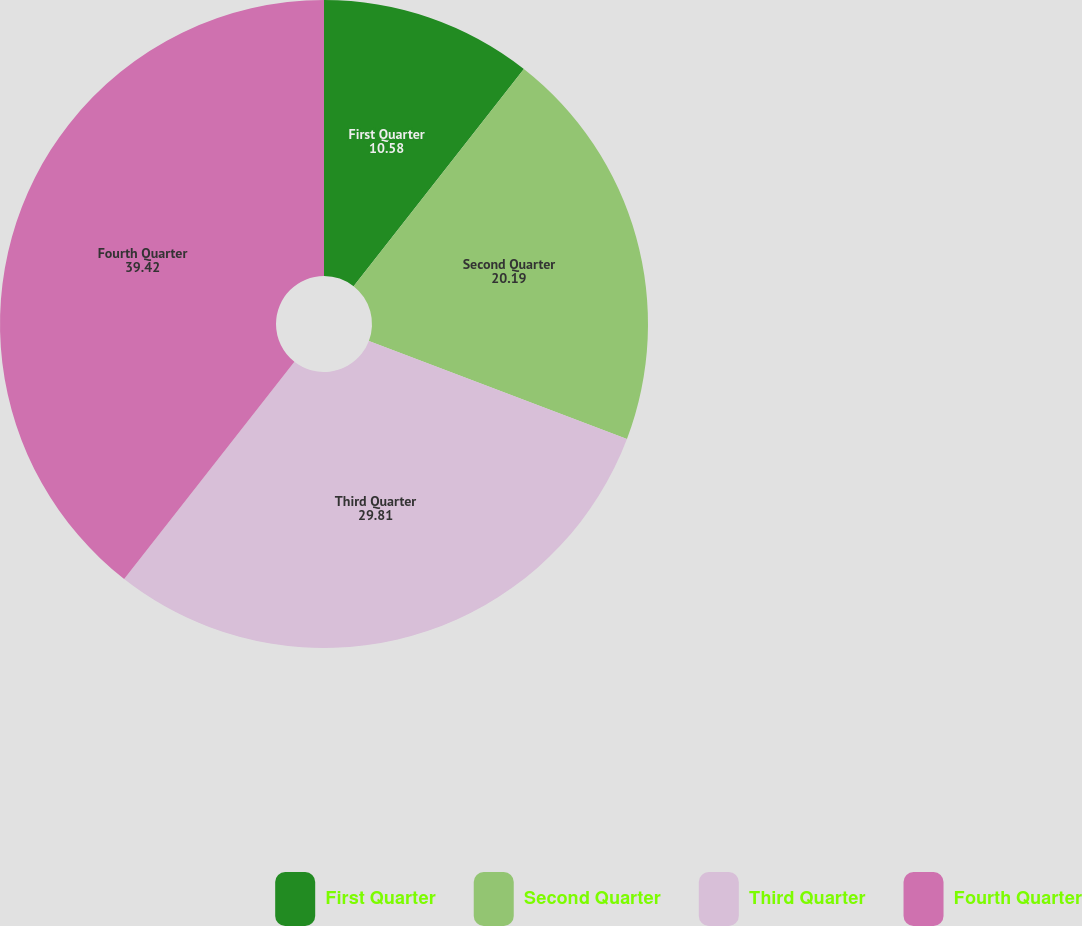Convert chart. <chart><loc_0><loc_0><loc_500><loc_500><pie_chart><fcel>First Quarter<fcel>Second Quarter<fcel>Third Quarter<fcel>Fourth Quarter<nl><fcel>10.58%<fcel>20.19%<fcel>29.81%<fcel>39.42%<nl></chart> 